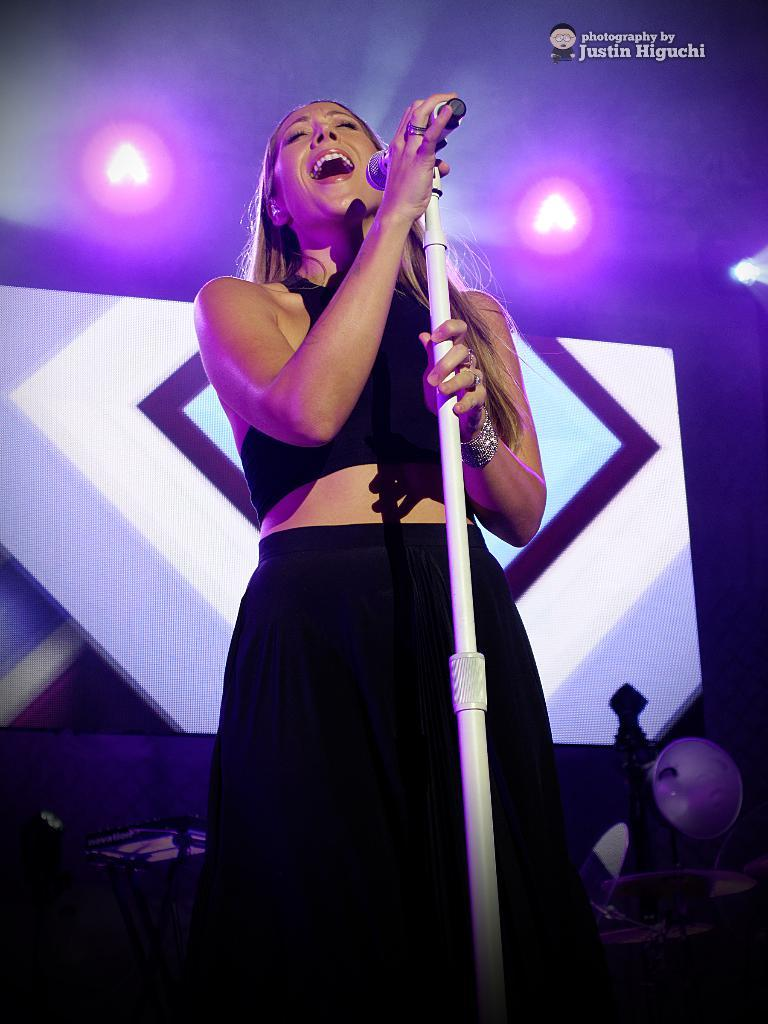What is the main subject of the image? The main subject of the image is a woman. What is the woman holding in the image? The woman is holding a mic with a stand. What can be seen in the background of the image? There are lights visible in the image. What type of bit is the woman using to control the horse in the image? There is no horse or bit present in the image; it features a woman holding a mic with a stand. How many sticks is the woman holding in the image? The woman is not holding any sticks in the image; she is holding a mic with a stand. 